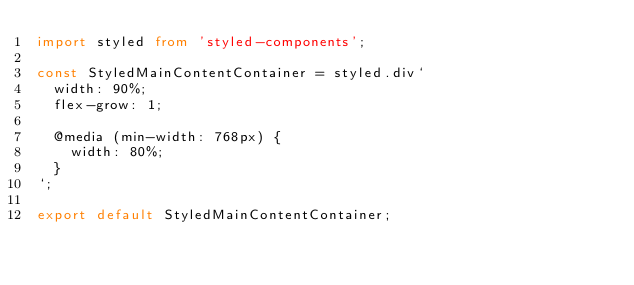Convert code to text. <code><loc_0><loc_0><loc_500><loc_500><_TypeScript_>import styled from 'styled-components';

const StyledMainContentContainer = styled.div`
  width: 90%;
  flex-grow: 1;

  @media (min-width: 768px) {
    width: 80%;
  }
`;

export default StyledMainContentContainer;
</code> 